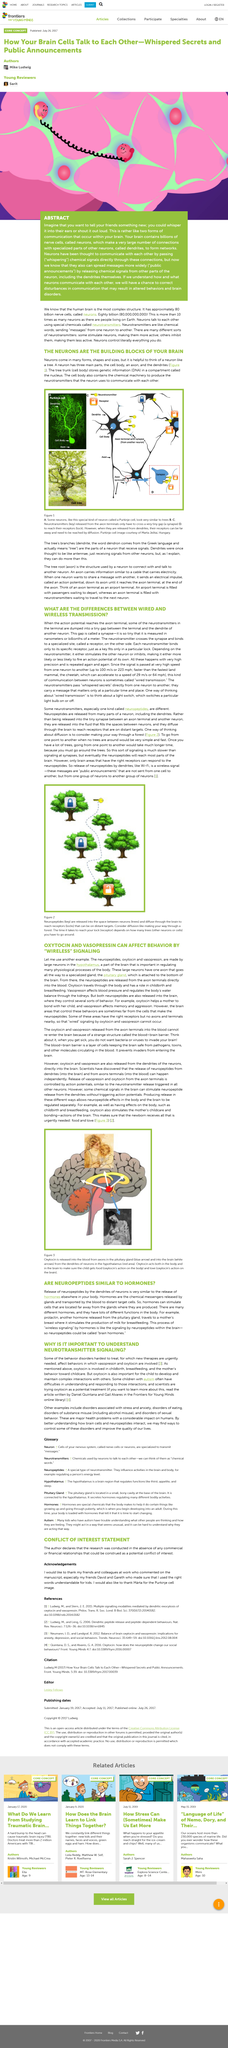List a handful of essential elements in this visual. In figure 2, we can see that the trees lack a lock, which suggests that the neurons depicted are undergoing neural transmutation. These neurons are unable to respond to the specific neuropeptides that are being depicted, indicating a disruption in the normal functioning of the neural network. The three main parts of a neuron are the cell body, the axon, and the dendrites. Diffusion is the process by which neuropeptides move through the brain. The word "dendrite" is derived from the Greek language and literally means "tree". This term is commonly used in the field of neurobiology to describe the branching structures found in neurons. Neurons communicate with each other through the release of neurotransmitters by their cell body. 